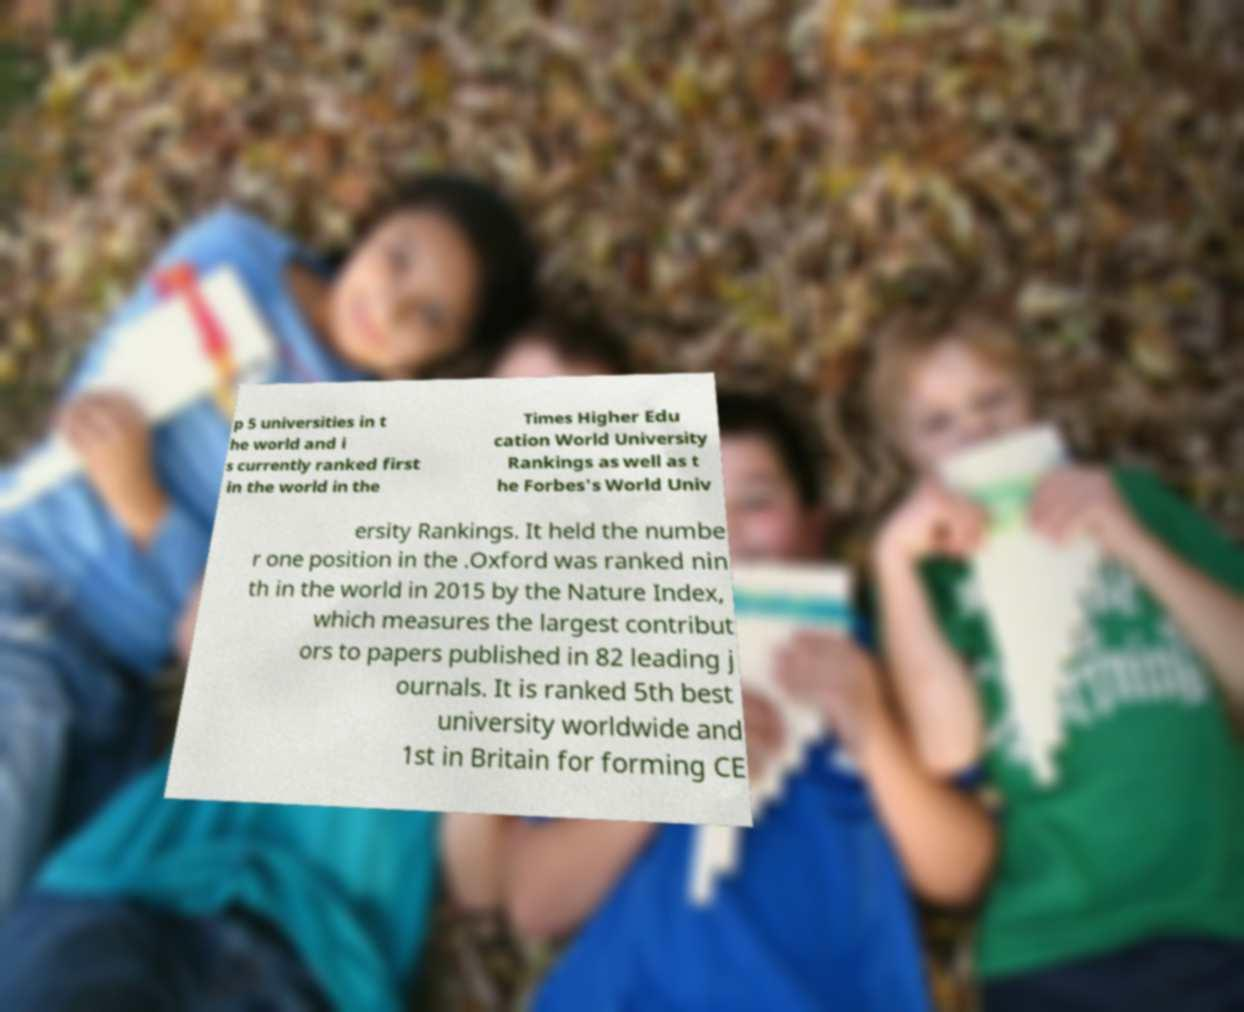Can you accurately transcribe the text from the provided image for me? p 5 universities in t he world and i s currently ranked first in the world in the Times Higher Edu cation World University Rankings as well as t he Forbes's World Univ ersity Rankings. It held the numbe r one position in the .Oxford was ranked nin th in the world in 2015 by the Nature Index, which measures the largest contribut ors to papers published in 82 leading j ournals. It is ranked 5th best university worldwide and 1st in Britain for forming CE 